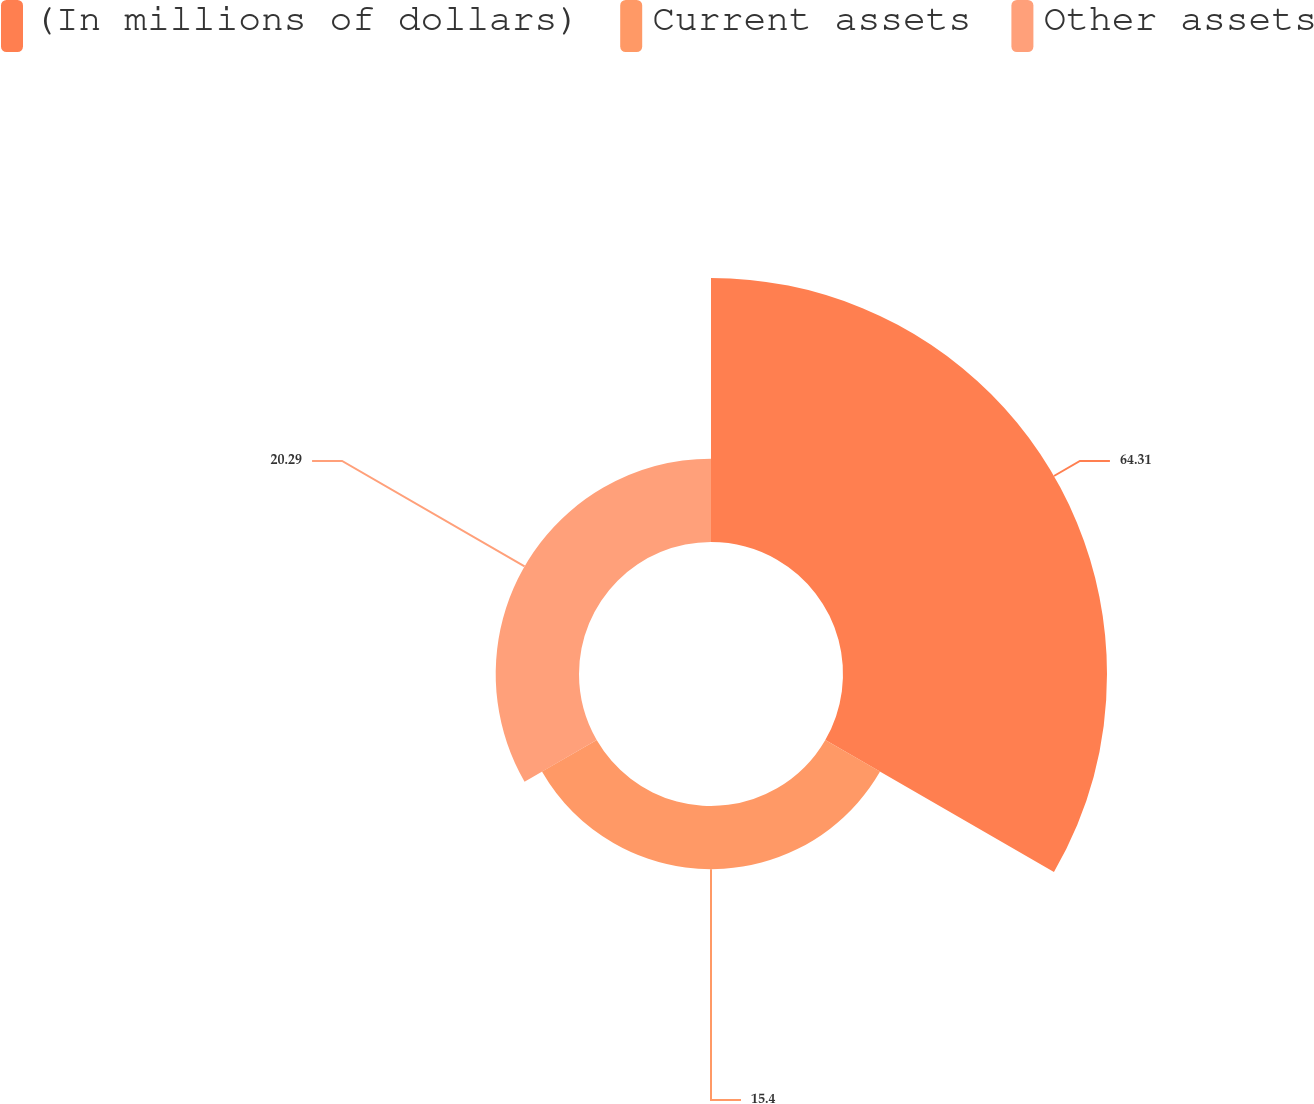<chart> <loc_0><loc_0><loc_500><loc_500><pie_chart><fcel>(In millions of dollars)<fcel>Current assets<fcel>Other assets<nl><fcel>64.31%<fcel>15.4%<fcel>20.29%<nl></chart> 